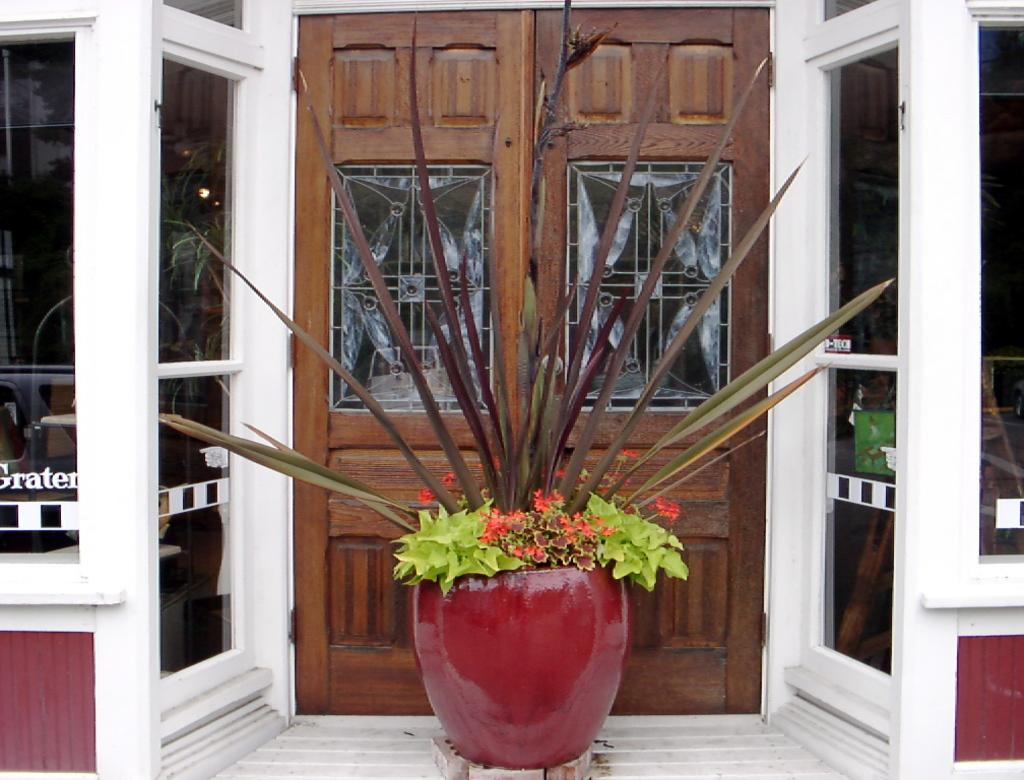What is located in the middle of the image? There is a plant pot in the middle of the image. What can be seen in the background of the image? There is a building in the background of the image. Can you describe any architectural features in the image? Yes, there is a door in the image. What type of volleyball game is being played in the image? There is no volleyball game present in the image. Can you describe the church in the image? There is no church present in the image. 